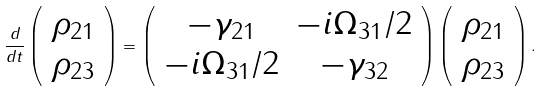<formula> <loc_0><loc_0><loc_500><loc_500>\frac { d } { d t } \left ( \begin{array} { c } \rho _ { 2 1 } \\ \rho _ { 2 3 } \\ \end{array} \right ) = \left ( \begin{array} { c c } - \gamma _ { 2 1 } & - i \Omega _ { 3 1 } / 2 \\ - i \Omega _ { 3 1 } / 2 & - \gamma _ { 3 2 } \\ \end{array} \right ) \left ( \begin{array} { c } \rho _ { 2 1 } \\ \rho _ { 2 3 } \\ \end{array} \right ) .</formula> 